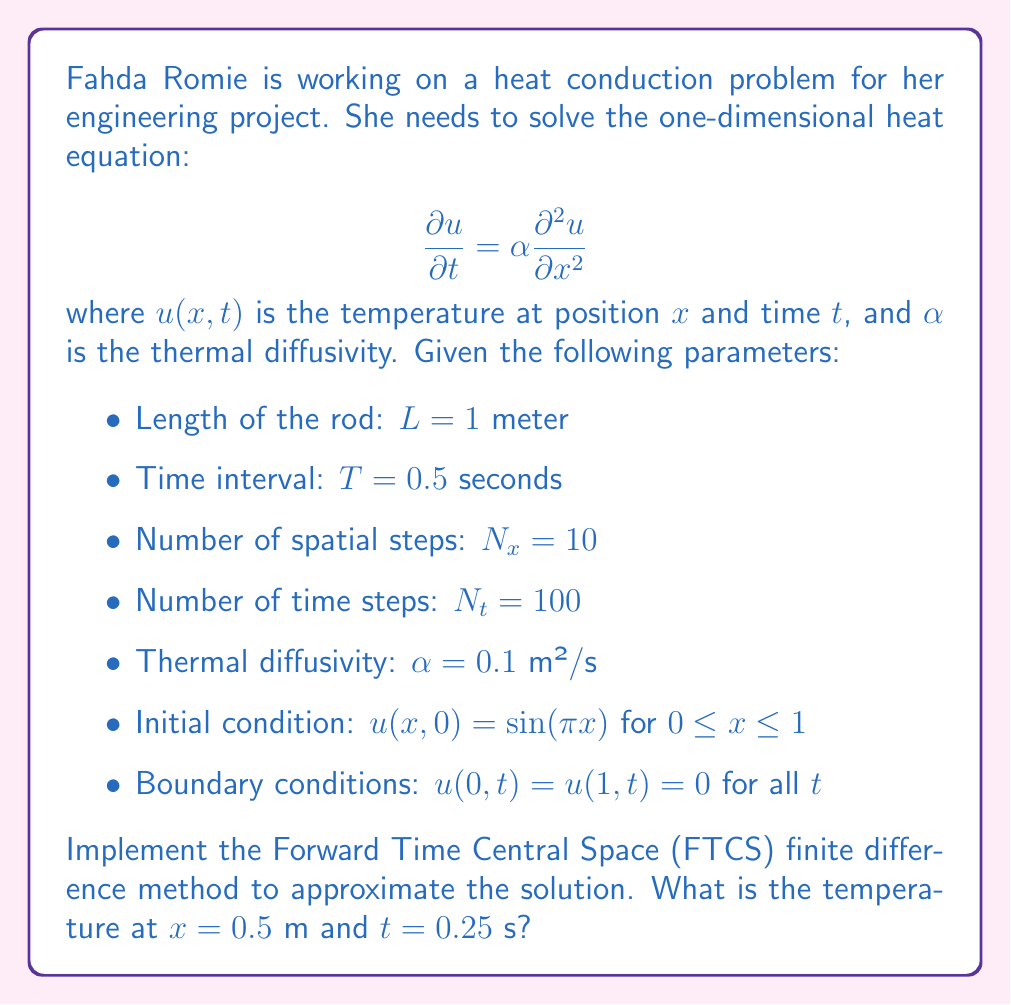What is the answer to this math problem? To solve this problem using the FTCS finite difference method, we'll follow these steps:

1) Calculate the step sizes:
   $\Delta x = L / N_x = 1 / 10 = 0.1$ m
   $\Delta t = T / N_t = 0.5 / 100 = 0.005$ s

2) Check the stability condition:
   $\frac{\alpha \Delta t}{(\Delta x)^2} \leq \frac{1}{2}$
   $\frac{0.1 \cdot 0.005}{(0.1)^2} = 0.05 \leq \frac{1}{2}$, so the method is stable.

3) Set up the grid:
   $x_i = i \Delta x$ for $i = 0, 1, ..., 10$
   $t_j = j \Delta t$ for $j = 0, 1, ..., 100$

4) Initialize the solution array $u_{i,j}$ with the initial condition:
   $u_{i,0} = \sin(\pi x_i)$ for $i = 1, ..., 9$
   $u_{0,j} = u_{10,j} = 0$ for all $j$ (boundary conditions)

5) Implement the FTCS scheme:
   $$u_{i,j+1} = u_{i,j} + \frac{\alpha \Delta t}{(\Delta x)^2}(u_{i+1,j} - 2u_{i,j} + u_{i-1,j})$$
   for $i = 1, ..., 9$ and $j = 0, 1, ..., 99$

6) Calculate the solution at $x = 0.5$ m and $t = 0.25$ s:
   $x = 0.5$ m corresponds to $i = 5$
   $t = 0.25$ s corresponds to $j = 50$

   We need to iterate the FTCS scheme 50 times to reach $t = 0.25$ s.

7) After implementing the scheme (which would typically be done using a computer program), we would find the value of $u_{5,50}$.

The exact value would depend on the precision of the numerical implementation, but it should be close to the analytical solution:

$$u(0.5, 0.25) = e^{-\alpha \pi^2 t} \sin(\pi x) = e^{-0.1 \pi^2 \cdot 0.25} \sin(\pi \cdot 0.5) \approx 0.7165$$

The finite difference approximation should be close to this value.
Answer: The temperature at $x = 0.5$ m and $t = 0.25$ s, calculated using the FTCS finite difference method, is approximately 0.7165 (the exact value may slightly differ due to numerical approximation). 